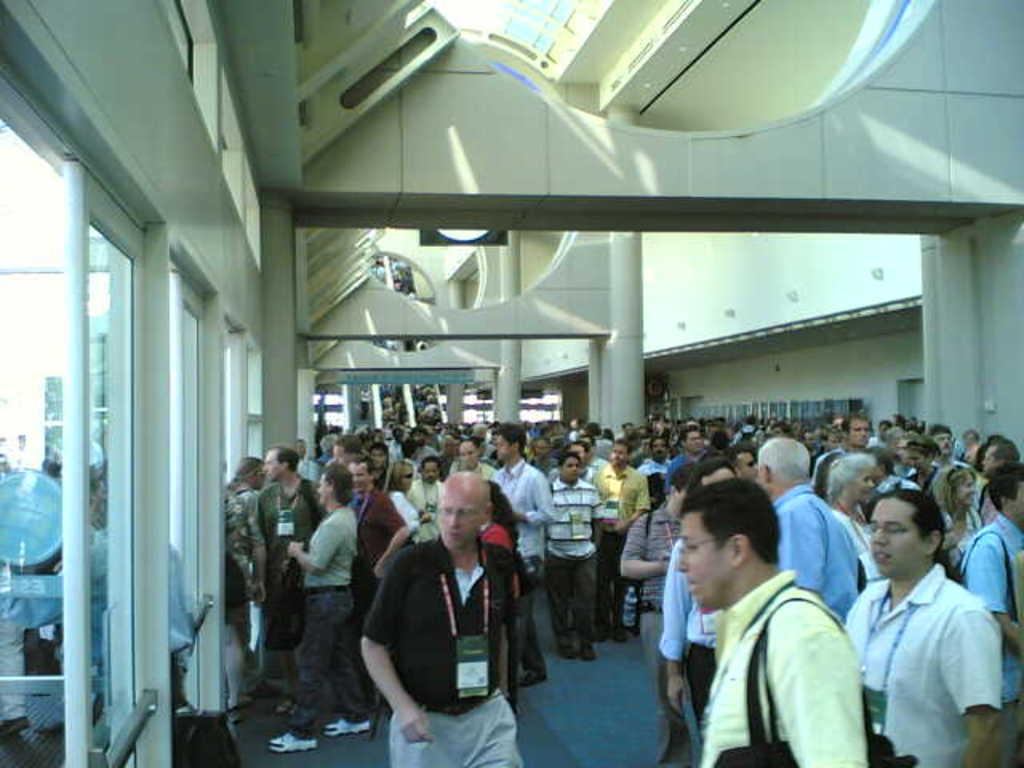What are the people in the image doing? The people in the image are standing and walking. What can be seen on the left side of the image? There are windows on the left side of the image. What feature is present in the image that allows entry or exit? There is a door in the image. What architectural elements can be seen in the background of the image? There are pillars and a wall in the background of the image. What expert advice can be seen on the wall in the image? There is no expert advice visible on the wall in the image. How many cars are parked in front of the building in the image? There are no cars present in the image. 